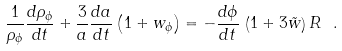Convert formula to latex. <formula><loc_0><loc_0><loc_500><loc_500>\frac { 1 } { \rho _ { \phi } } \frac { d \rho _ { \phi } } { d t } + \frac { 3 } { a } \frac { d a } { d t } \left ( 1 + w _ { \phi } \right ) = - \frac { d \phi } { d t } \, \left ( 1 + 3 \tilde { w } \right ) R \ .</formula> 